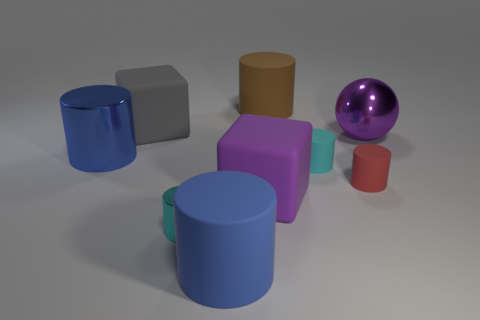There is a matte cube behind the big purple metallic thing; what color is it?
Keep it short and to the point. Gray. How many metallic things are blue objects or purple spheres?
Offer a terse response. 2. There is a small rubber thing that is the same color as the small metallic object; what is its shape?
Your answer should be compact. Cylinder. How many red objects are the same size as the brown matte object?
Provide a succinct answer. 0. There is a big object that is both behind the big purple matte cube and in front of the purple metal ball; what color is it?
Keep it short and to the point. Blue. How many things are either green rubber objects or blue rubber cylinders?
Provide a succinct answer. 1. How many small things are cyan rubber cylinders or brown rubber cylinders?
Give a very brief answer. 1. What size is the cylinder that is both in front of the small cyan matte object and behind the tiny metallic thing?
Offer a terse response. Small. There is a large object that is right of the large brown rubber object; is it the same color as the large rubber block to the right of the cyan metal thing?
Your answer should be compact. Yes. What number of other objects are the same material as the red object?
Offer a very short reply. 5. 